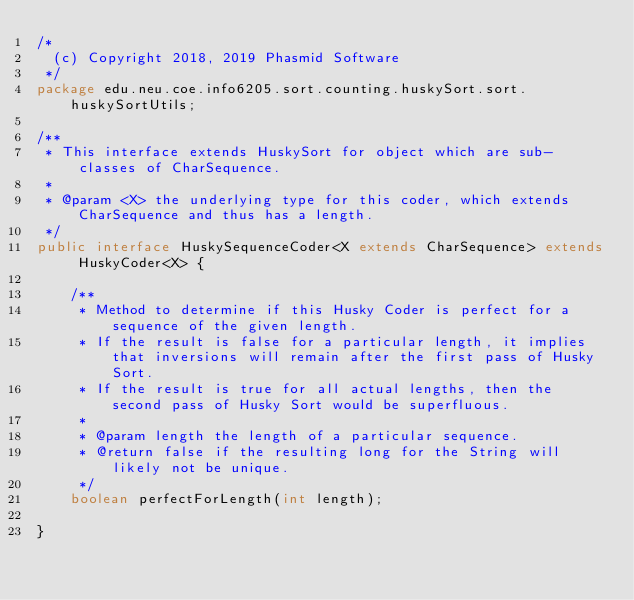Convert code to text. <code><loc_0><loc_0><loc_500><loc_500><_Java_>/*
  (c) Copyright 2018, 2019 Phasmid Software
 */
package edu.neu.coe.info6205.sort.counting.huskySort.sort.huskySortUtils;

/**
 * This interface extends HuskySort for object which are sub-classes of CharSequence.
 *
 * @param <X> the underlying type for this coder, which extends CharSequence and thus has a length.
 */
public interface HuskySequenceCoder<X extends CharSequence> extends HuskyCoder<X> {

    /**
     * Method to determine if this Husky Coder is perfect for a sequence of the given length.
     * If the result is false for a particular length, it implies that inversions will remain after the first pass of Husky Sort.
     * If the result is true for all actual lengths, then the second pass of Husky Sort would be superfluous.
     *
     * @param length the length of a particular sequence.
     * @return false if the resulting long for the String will likely not be unique.
     */
    boolean perfectForLength(int length);

}
</code> 